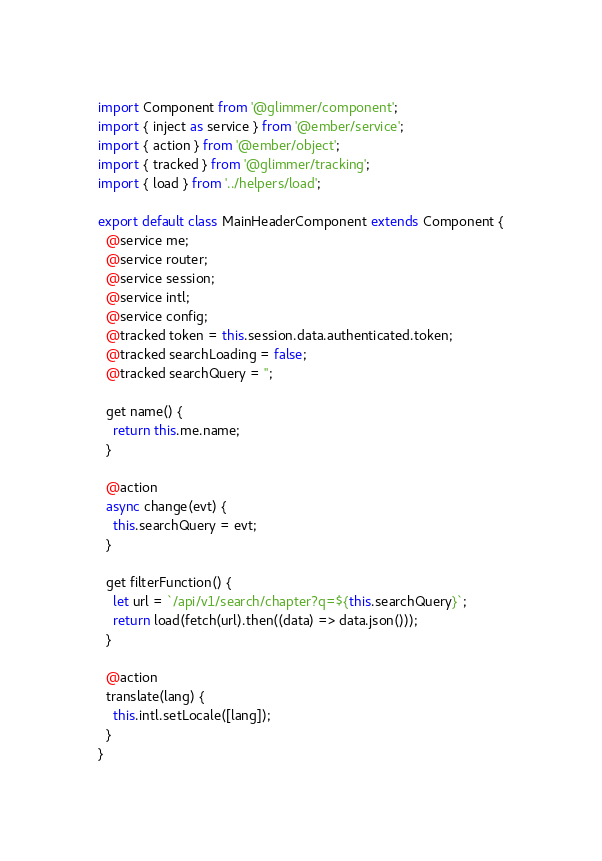Convert code to text. <code><loc_0><loc_0><loc_500><loc_500><_JavaScript_>import Component from '@glimmer/component';
import { inject as service } from '@ember/service';
import { action } from '@ember/object';
import { tracked } from '@glimmer/tracking';
import { load } from '../helpers/load';

export default class MainHeaderComponent extends Component {
  @service me;
  @service router;
  @service session;
  @service intl;
  @service config;
  @tracked token = this.session.data.authenticated.token;
  @tracked searchLoading = false;
  @tracked searchQuery = '';

  get name() {
    return this.me.name;
  }

  @action
  async change(evt) {
    this.searchQuery = evt;
  }

  get filterFunction() {
    let url = `/api/v1/search/chapter?q=${this.searchQuery}`;
    return load(fetch(url).then((data) => data.json()));
  }

  @action
  translate(lang) {
    this.intl.setLocale([lang]);
  }
}
</code> 